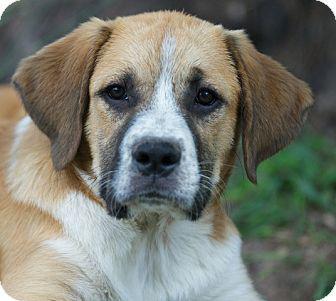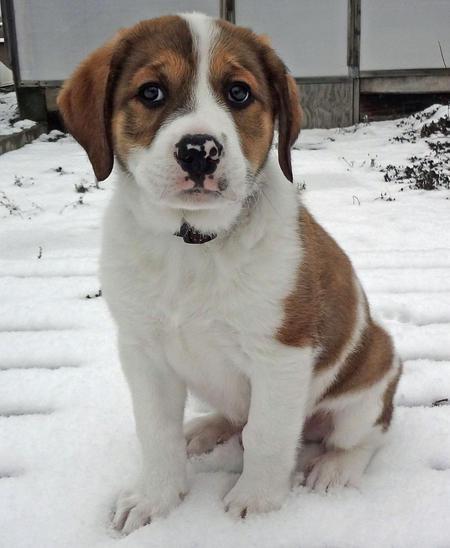The first image is the image on the left, the second image is the image on the right. For the images displayed, is the sentence "One dog is on a leash." factually correct? Answer yes or no. No. The first image is the image on the left, the second image is the image on the right. For the images displayed, is the sentence "One image shows a dog with a tail curled inward, standing on all fours with its body in profile and wearing a collar." factually correct? Answer yes or no. No. 